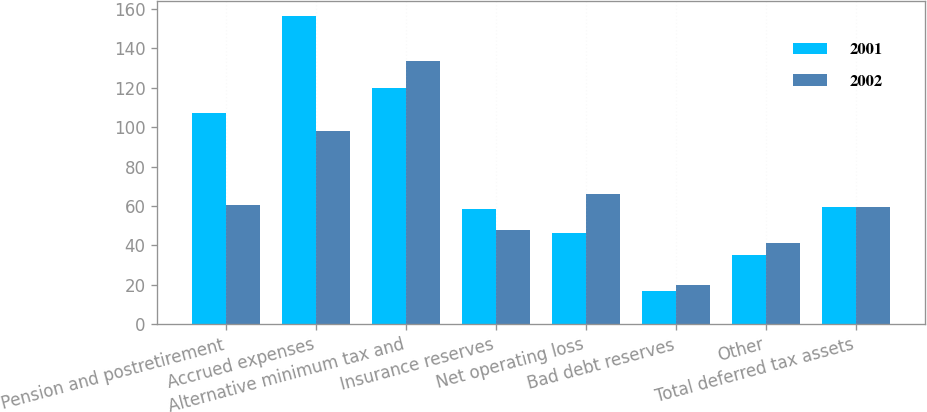Convert chart to OTSL. <chart><loc_0><loc_0><loc_500><loc_500><stacked_bar_chart><ecel><fcel>Pension and postretirement<fcel>Accrued expenses<fcel>Alternative minimum tax and<fcel>Insurance reserves<fcel>Net operating loss<fcel>Bad debt reserves<fcel>Other<fcel>Total deferred tax assets<nl><fcel>2001<fcel>107.2<fcel>156.3<fcel>120.1<fcel>58.3<fcel>46.3<fcel>16.9<fcel>35.3<fcel>59.4<nl><fcel>2002<fcel>60.5<fcel>98.3<fcel>133.5<fcel>47.8<fcel>66.2<fcel>19.8<fcel>41<fcel>59.4<nl></chart> 